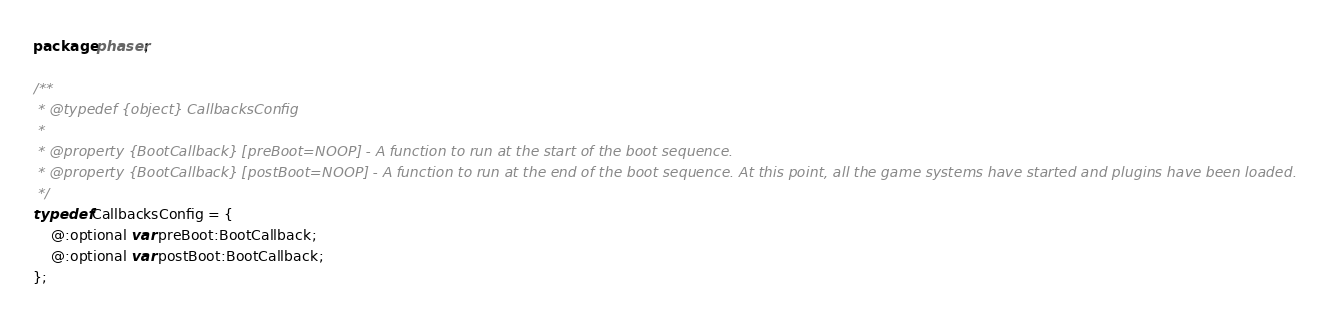<code> <loc_0><loc_0><loc_500><loc_500><_Haxe_>package phaser;

/**
 * @typedef {object} CallbacksConfig
 *
 * @property {BootCallback} [preBoot=NOOP] - A function to run at the start of the boot sequence.
 * @property {BootCallback} [postBoot=NOOP] - A function to run at the end of the boot sequence. At this point, all the game systems have started and plugins have been loaded.
 */
typedef CallbacksConfig = {
    @:optional var preBoot:BootCallback;
    @:optional var postBoot:BootCallback;
};
</code> 